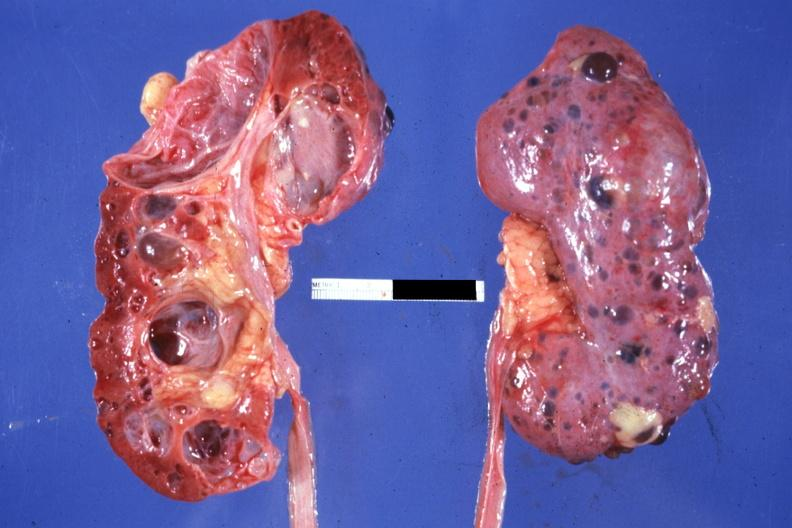how many kidney does this image show nice photo opened the other from capsular surface many cysts?
Answer the question using a single word or phrase. One 